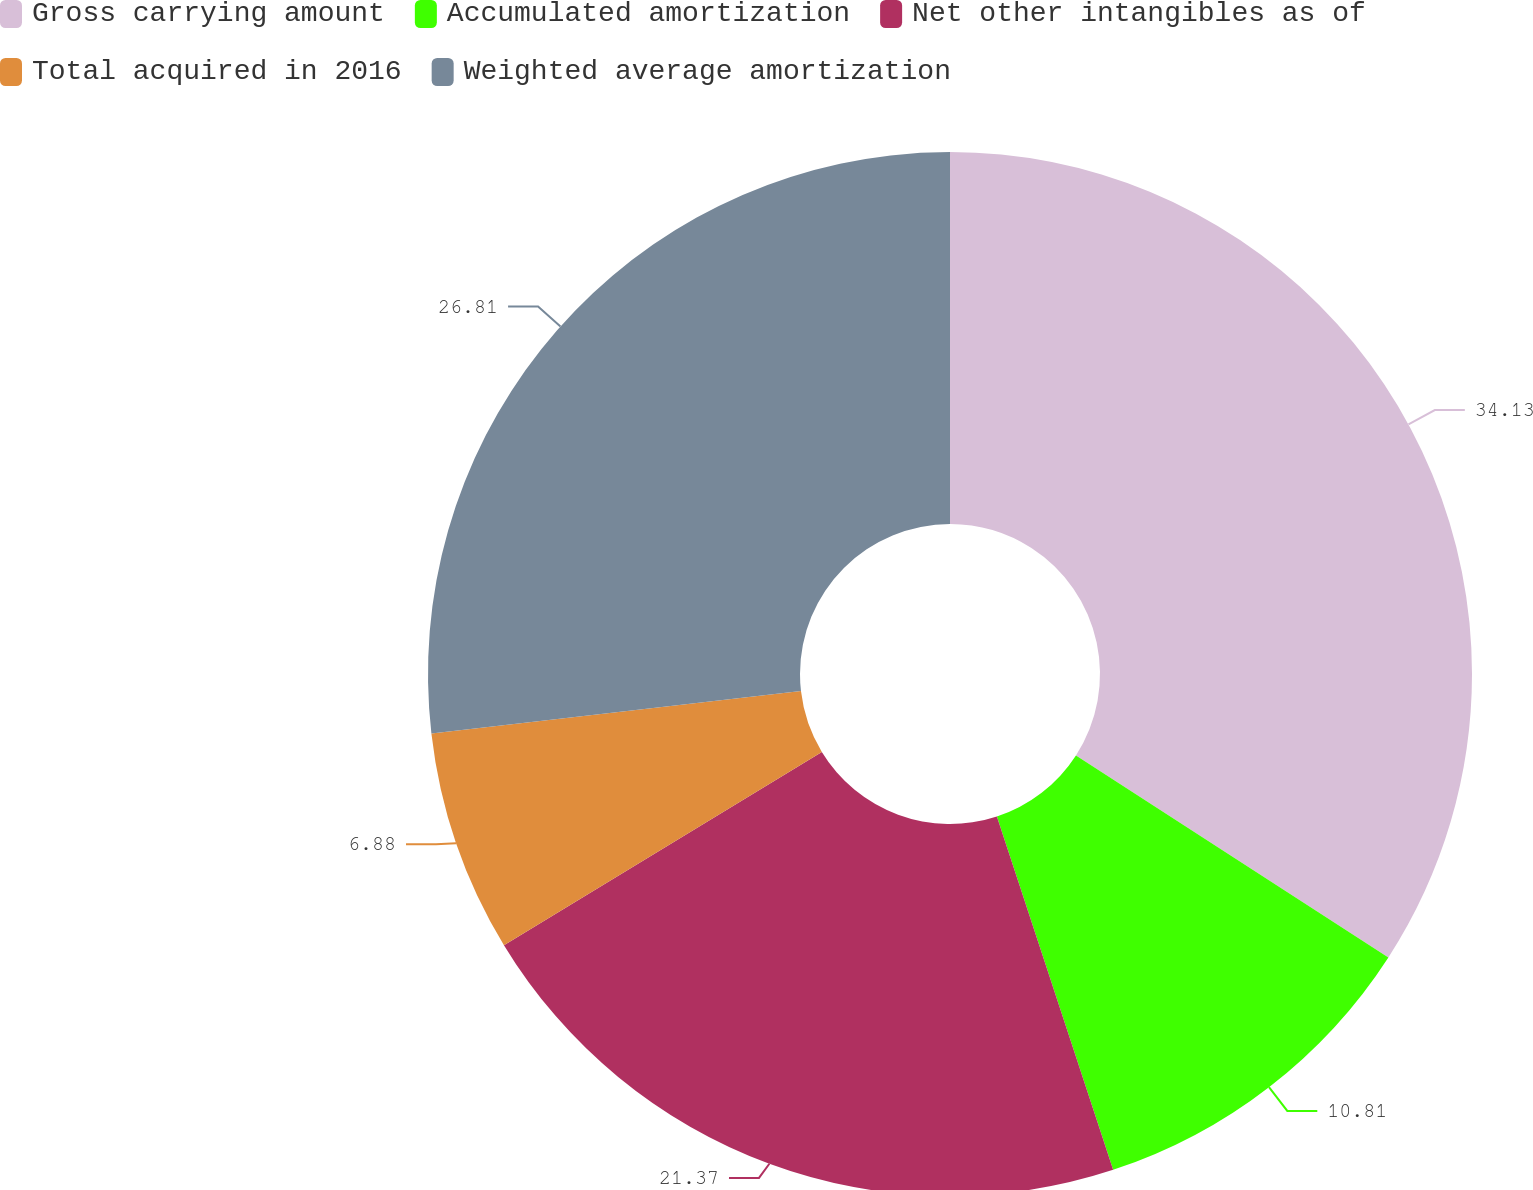Convert chart. <chart><loc_0><loc_0><loc_500><loc_500><pie_chart><fcel>Gross carrying amount<fcel>Accumulated amortization<fcel>Net other intangibles as of<fcel>Total acquired in 2016<fcel>Weighted average amortization<nl><fcel>34.14%<fcel>10.81%<fcel>21.37%<fcel>6.88%<fcel>26.82%<nl></chart> 